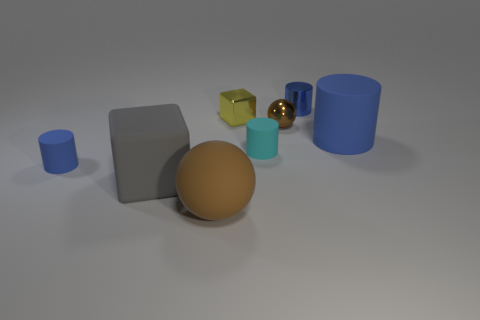Subtract all small cyan cylinders. How many cylinders are left? 3 Add 1 spheres. How many objects exist? 9 Subtract all red cubes. How many blue cylinders are left? 3 Subtract 3 cylinders. How many cylinders are left? 1 Subtract all gray blocks. How many blocks are left? 1 Subtract all spheres. How many objects are left? 6 Subtract all yellow cubes. Subtract all gray spheres. How many cubes are left? 1 Subtract all blue cylinders. Subtract all tiny red things. How many objects are left? 5 Add 1 cyan rubber cylinders. How many cyan rubber cylinders are left? 2 Add 4 blue cylinders. How many blue cylinders exist? 7 